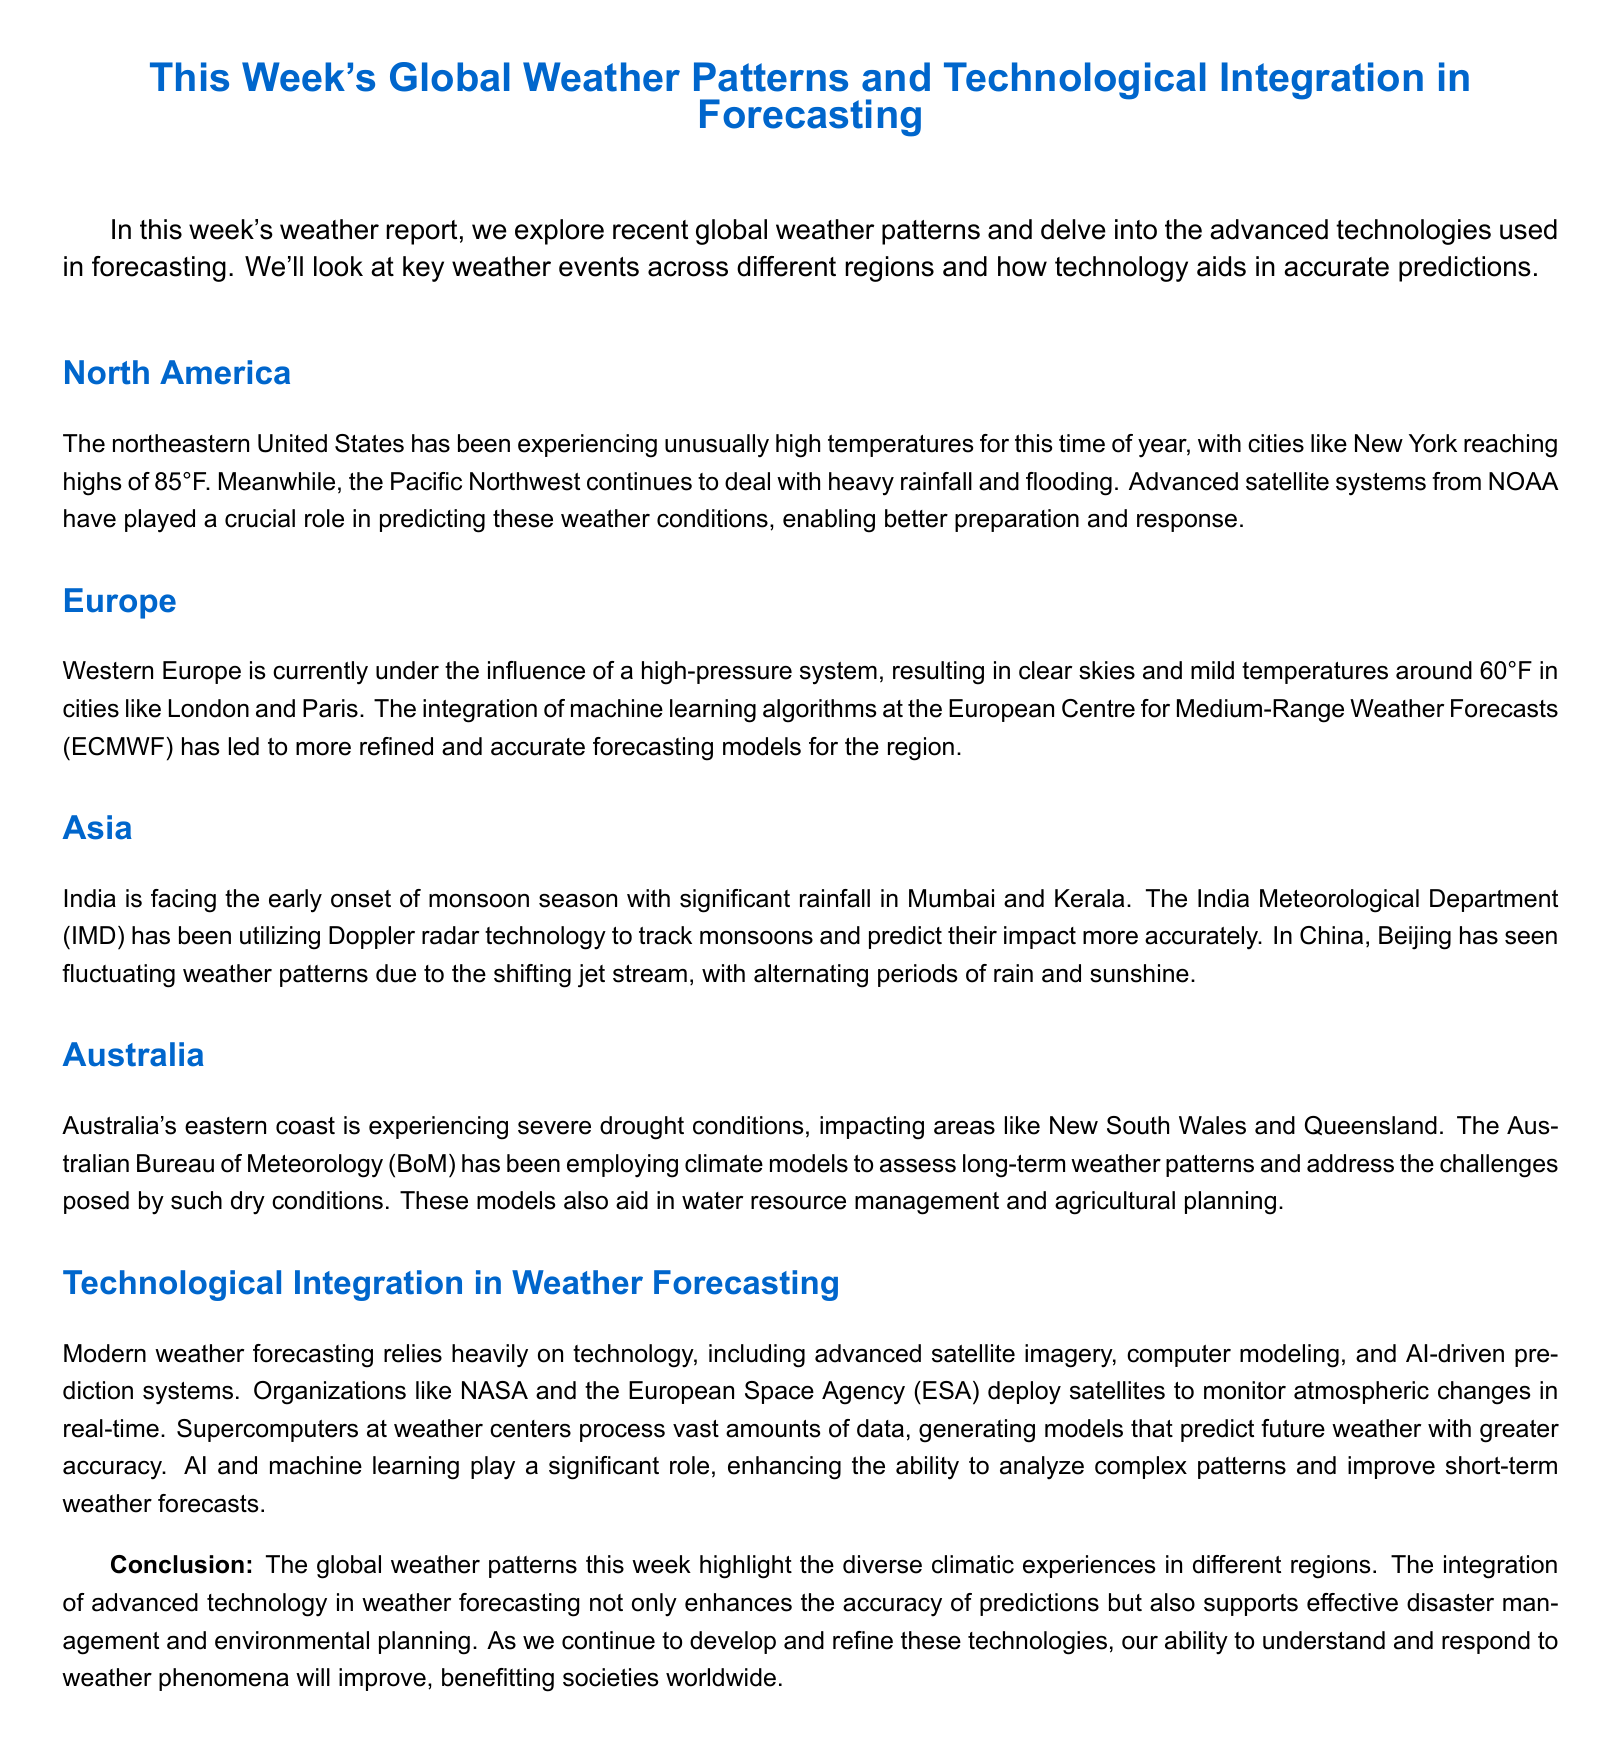What is the high temperature expected in New York? The high temperature expected in New York is mentioned as 85°F in the document.
Answer: 85°F Which regions of Australia are experiencing drought? The regions of Australia facing drought conditions are specified as New South Wales and Queensland.
Answer: New South Wales and Queensland What technology is being used by the IMD to track monsoon? The India Meteorological Department (IMD) uses Doppler radar technology to track monsoons, as stated in the document.
Answer: Doppler radar What weather pattern is affecting Western Europe? The document notes that Western Europe is under the influence of a high-pressure system, impacting the weather conditions there.
Answer: High-pressure system How do modern weather forecasting systems aid predictions? Modern weather forecasting systems utilize advanced technologies, such as AI-driven prediction systems, which enhance the ability to analyze complex weather patterns, according to the document.
Answer: AI-driven prediction systems Which organization utilizes advanced satellite systems for weather predictions in North America? The National Oceanic and Atmospheric Administration (NOAA) is mentioned in the document as the organization using advanced satellite systems for weather predictions.
Answer: NOAA How is technology aiding the Australian Bureau of Meteorology? The Australian Bureau of Meteorology uses climate models to assess long-term weather patterns impacted by drought conditions, as outlined in the document.
Answer: Climate models What ensures better accuracy in European weather forecasts? The integration of machine learning algorithms at the European Centre for Medium-Range Weather Forecasts (ECMWF) ensures better accuracy in weather forecasts for Europe.
Answer: Machine learning algorithms What is the purpose of supercomputers in weather forecasting? Supercomputers at weather centers process vast amounts of data to generate models that predict future weather with greater accuracy, as mentioned in the document.
Answer: Process vast amounts of data 